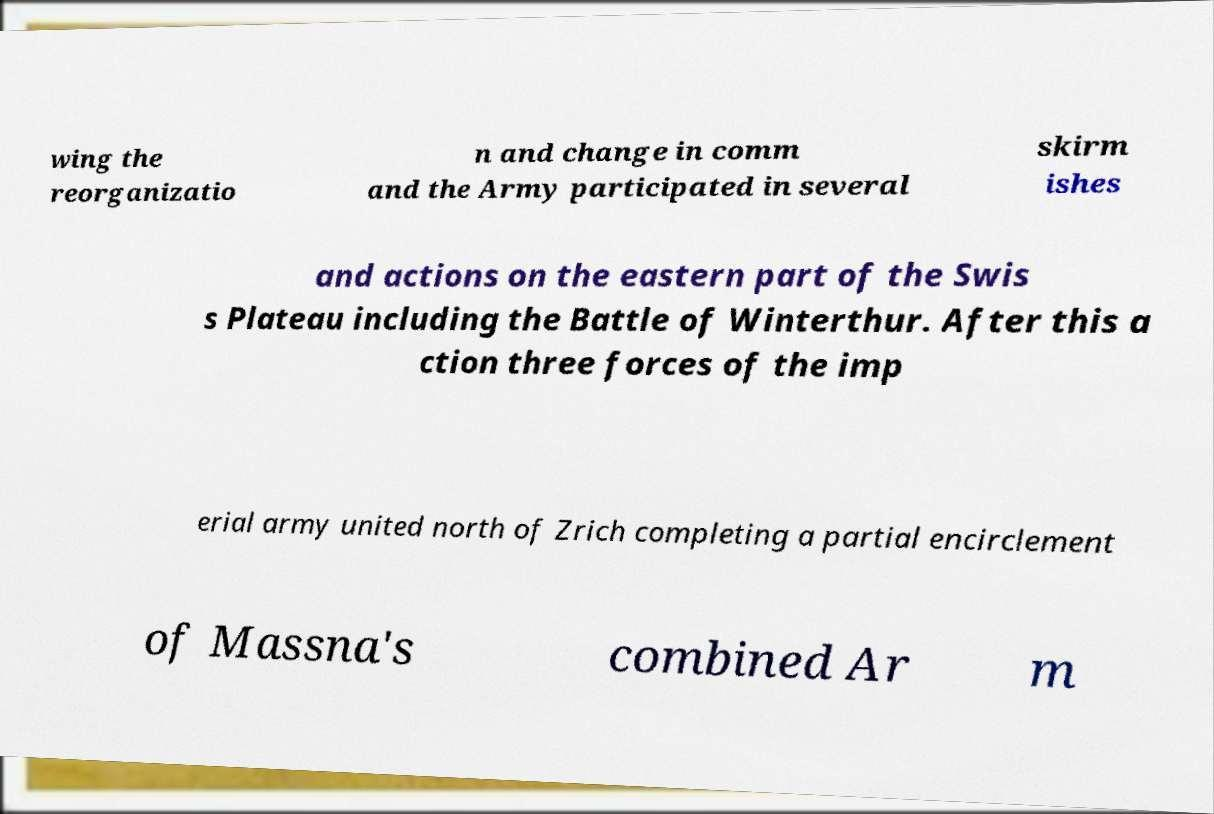Please identify and transcribe the text found in this image. wing the reorganizatio n and change in comm and the Army participated in several skirm ishes and actions on the eastern part of the Swis s Plateau including the Battle of Winterthur. After this a ction three forces of the imp erial army united north of Zrich completing a partial encirclement of Massna's combined Ar m 